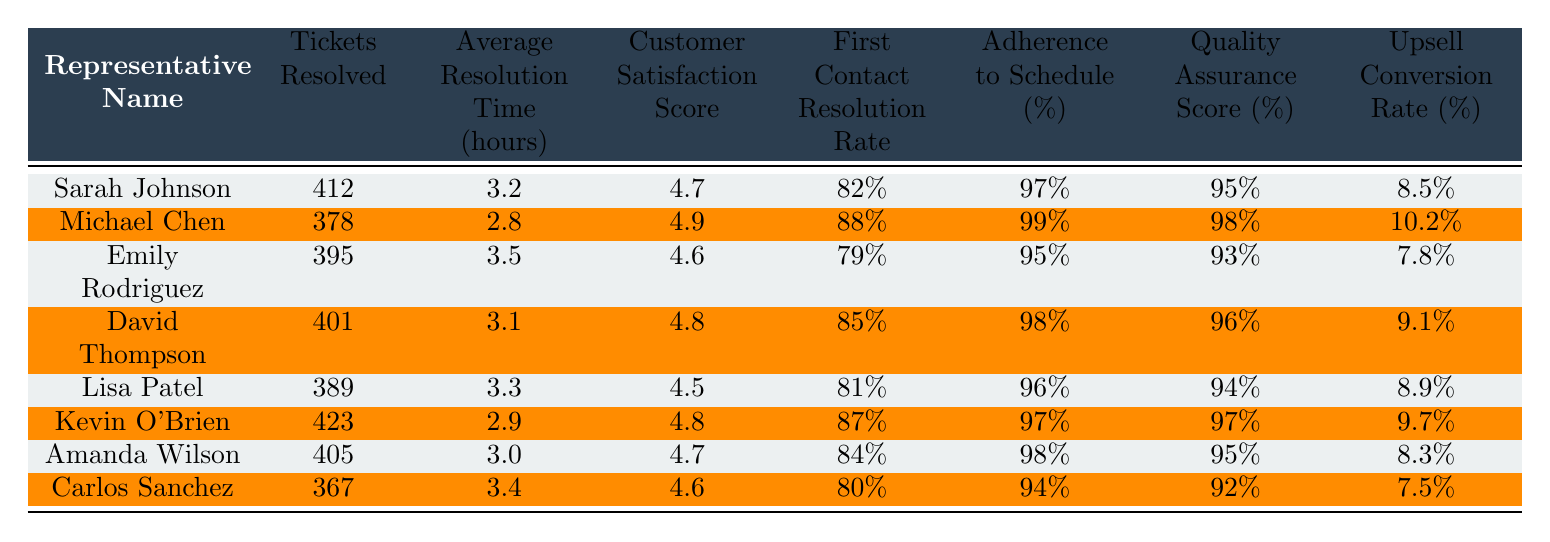What is the highest customer satisfaction score among the representatives? Looking at the "Customer Satisfaction Score" column, the highest score is 4.9, which belongs to Michael Chen.
Answer: 4.9 Who resolved the most tickets? By checking the "Tickets Resolved" column, Kevin O'Brien resolved the most tickets, totaling 423.
Answer: Kevin O'Brien What is the average resolution time for all representatives? To find the average resolution time, sum up the values (3.2 + 2.8 + 3.5 + 3.1 + 3.3 + 2.9 + 3.0 + 3.4) = 22.2 hours and divide by 8 (total representatives), resulting in an average of 2.775 hours.
Answer: 3.0 hours Is there a representative whose first contact resolution rate is above 85%? By examining the "First Contact Resolution Rate" column, Sarah Johnson (82%), Michael Chen (88%), David Thompson (85%), Kevin O'Brien (87%), and Amanda Wilson (84%) all meet this criterion. Michael Chen and David Thompson are above 85%.
Answer: Yes Which representative has the lowest upsell conversion rate? In the "Upsell Conversion Rate" column, Carlos Sanchez has the lowest rate at 7.5%.
Answer: Carlos Sanchez What is the adherence to schedule percentage for the representative with the second highest ticket resolutions? Michael Chen has the second highest ticket resolutions with 378 and his adherence to schedule is 99%.
Answer: 99% If we consider only representatives with a customer satisfaction score above 4.6, how many representatives are there? The representatives with scores above 4.6 are Michael Chen (4.9), David Thompson (4.8), Kevin O'Brien (4.8), Sarah Johnson (4.7), and Amanda Wilson (4.7), totaling 5 representatives.
Answer: 5 What is the difference in quality assurance score between the highest and lowest representatives? The highest quality assurance score is held by Michael Chen (98%) and the lowest by Carlos Sanchez (92%). The difference is calculated as 98% - 92% = 6%.
Answer: 6% Which representative has the highest adherence to schedule and what is that percentage? Kevin O'Brien has the highest adherence to schedule at 97%.
Answer: 97% What is the average first contact resolution rate for all representatives? To find the average first contact resolution rate, add up the percentages (82 + 88 + 79 + 85 + 81 + 87 + 84 + 80) = 666 and divide by 8 (total representatives), resulting in an average of 83.25%.
Answer: 83.25% Which representative has the highest quality assurance score and what is the value? The highest quality assurance score is 98%, achieved by Michael Chen.
Answer: 98% 